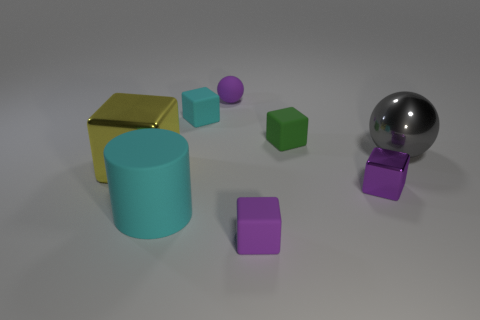What number of things are small green matte cubes behind the large yellow cube or large cyan spheres?
Give a very brief answer. 1. Are there fewer small blocks that are left of the purple sphere than large rubber objects right of the big sphere?
Your response must be concise. No. There is a cyan matte cylinder; are there any gray metallic spheres behind it?
Your answer should be very brief. Yes. What number of things are large objects in front of the large yellow thing or tiny purple rubber objects that are on the left side of the small purple metallic thing?
Give a very brief answer. 3. How many small things are the same color as the large rubber object?
Your answer should be compact. 1. What is the color of the tiny matte thing that is the same shape as the large gray object?
Give a very brief answer. Purple. What shape is the object that is behind the large yellow metallic object and right of the small green matte thing?
Keep it short and to the point. Sphere. Is the number of purple rubber cubes greater than the number of red rubber cylinders?
Your answer should be very brief. Yes. What is the big cyan object made of?
Provide a short and direct response. Rubber. Is there anything else that has the same size as the cyan matte cube?
Your answer should be compact. Yes. 